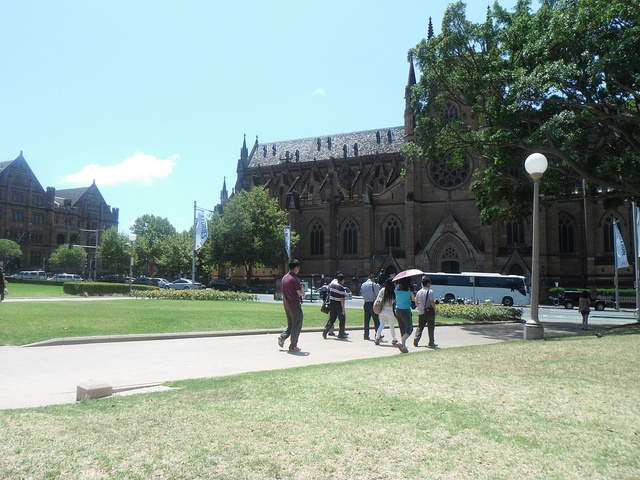Describe the objects in this image and their specific colors. I can see car in lightblue, black, gray, and navy tones, bus in lightblue, gray, black, and navy tones, people in lightblue, black, gray, and purple tones, people in lightblue, black, teal, blue, and gray tones, and people in lightblue, darkgray, black, gray, and lightgray tones in this image. 